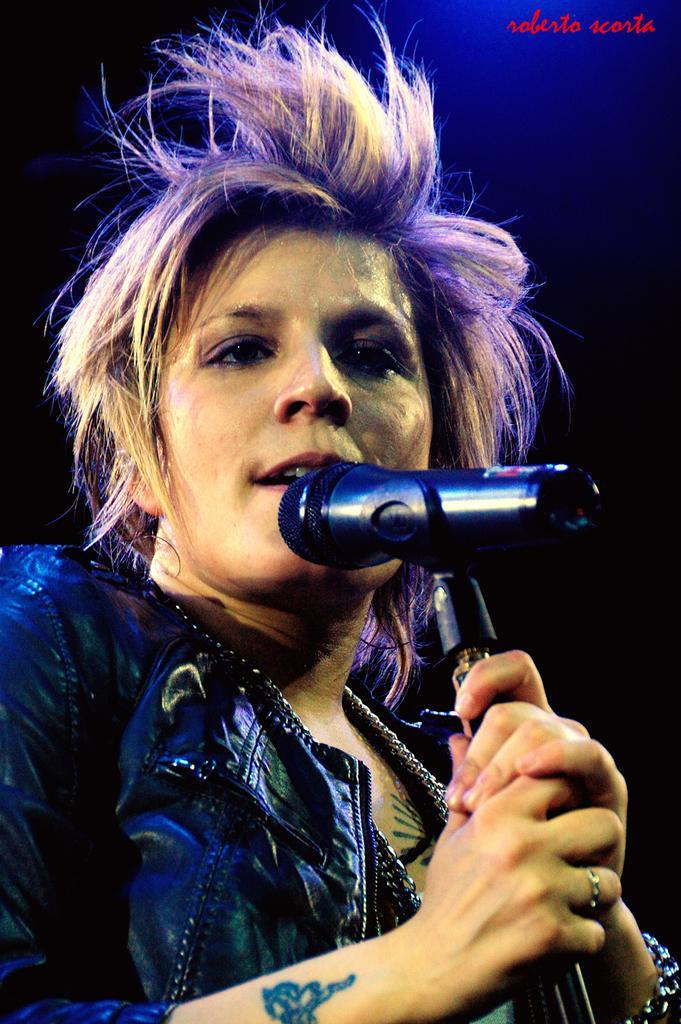Describe this image in one or two sentences. Here is a woman holding a microphone and singing she has a ring on her right hand ring finger and she has a tattoo on her hand she is wearing a black color jacket 